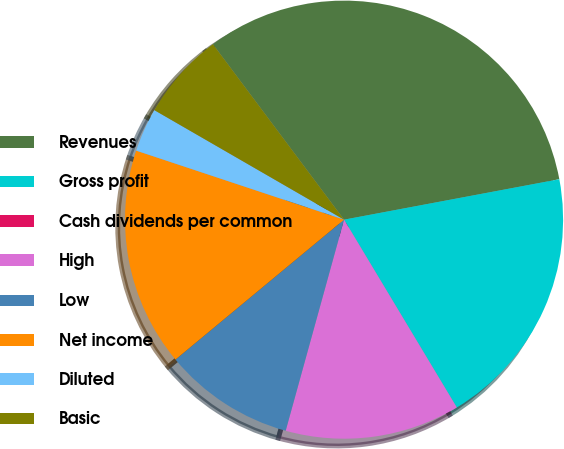Convert chart. <chart><loc_0><loc_0><loc_500><loc_500><pie_chart><fcel>Revenues<fcel>Gross profit<fcel>Cash dividends per common<fcel>High<fcel>Low<fcel>Net income<fcel>Diluted<fcel>Basic<nl><fcel>32.26%<fcel>19.35%<fcel>0.0%<fcel>12.9%<fcel>9.68%<fcel>16.13%<fcel>3.23%<fcel>6.45%<nl></chart> 